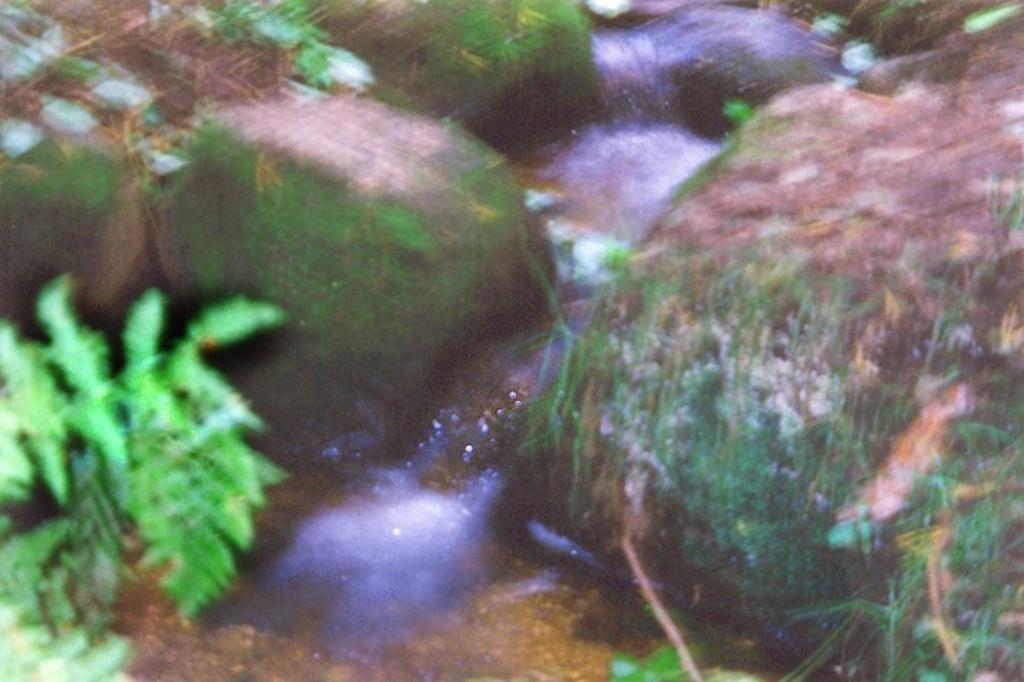How would you summarize this image in a sentence or two? This picture shows plants and water and we see rocks. 